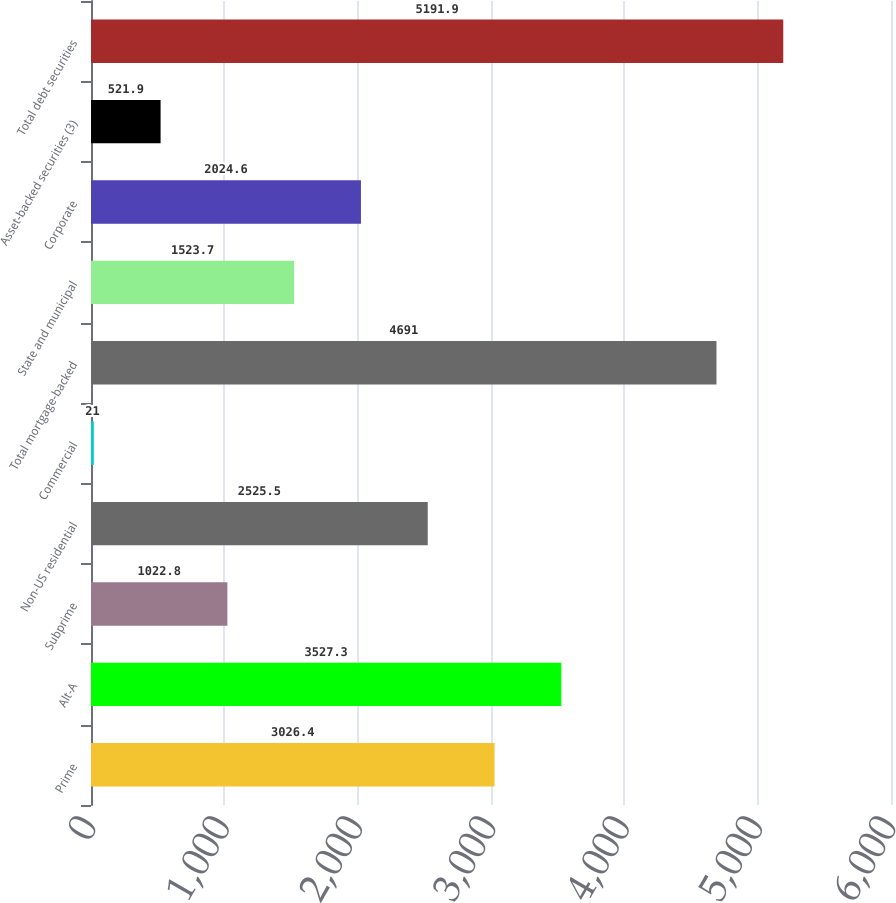Convert chart to OTSL. <chart><loc_0><loc_0><loc_500><loc_500><bar_chart><fcel>Prime<fcel>Alt-A<fcel>Subprime<fcel>Non-US residential<fcel>Commercial<fcel>Total mortgage-backed<fcel>State and municipal<fcel>Corporate<fcel>Asset-backed securities (3)<fcel>Total debt securities<nl><fcel>3026.4<fcel>3527.3<fcel>1022.8<fcel>2525.5<fcel>21<fcel>4691<fcel>1523.7<fcel>2024.6<fcel>521.9<fcel>5191.9<nl></chart> 